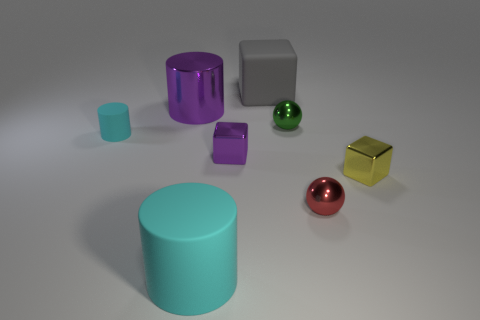Add 1 cyan rubber things. How many objects exist? 9 Subtract all spheres. How many objects are left? 6 Subtract 1 gray blocks. How many objects are left? 7 Subtract all large purple rubber cylinders. Subtract all small cyan objects. How many objects are left? 7 Add 3 big gray objects. How many big gray objects are left? 4 Add 2 small cyan cylinders. How many small cyan cylinders exist? 3 